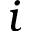<formula> <loc_0><loc_0><loc_500><loc_500>i</formula> 